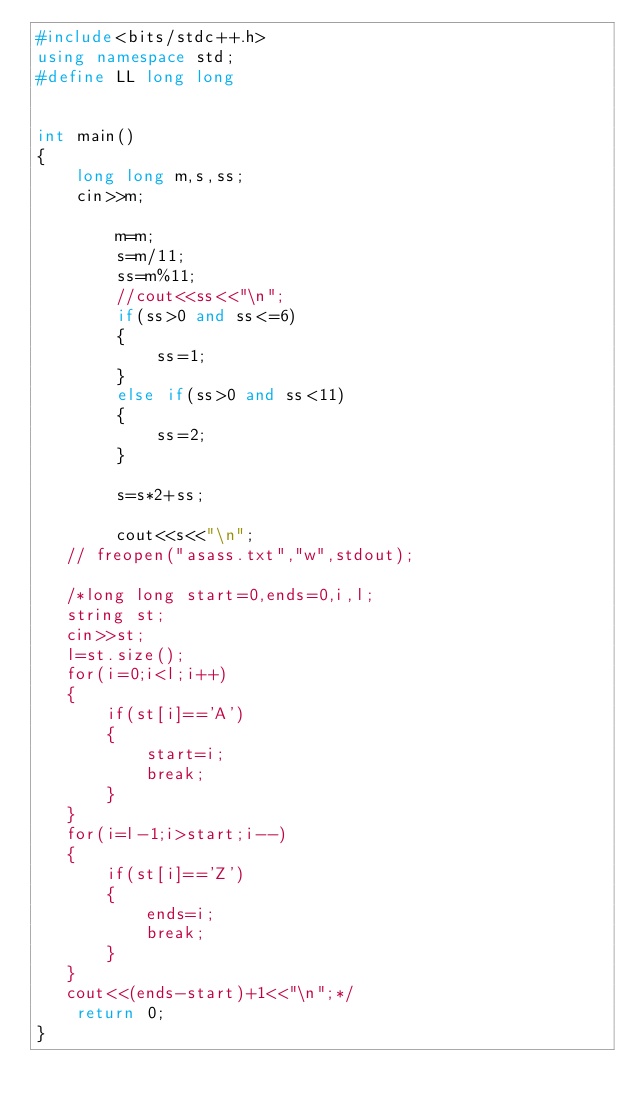Convert code to text. <code><loc_0><loc_0><loc_500><loc_500><_C++_>#include<bits/stdc++.h>
using namespace std;
#define LL long long


int main()
{
    long long m,s,ss;
    cin>>m;

        m=m;
        s=m/11;
        ss=m%11;
        //cout<<ss<<"\n";
        if(ss>0 and ss<=6)
        {
            ss=1;
        }
        else if(ss>0 and ss<11)
        {
            ss=2;
        }

        s=s*2+ss;

        cout<<s<<"\n";
   // freopen("asass.txt","w",stdout);

   /*long long start=0,ends=0,i,l;
   string st;
   cin>>st;
   l=st.size();
   for(i=0;i<l;i++)
   {
       if(st[i]=='A')
       {
           start=i;
           break;
       }
   }
   for(i=l-1;i>start;i--)
   {
       if(st[i]=='Z')
       {
           ends=i;
           break;
       }
   }
   cout<<(ends-start)+1<<"\n";*/
    return 0;
}
</code> 